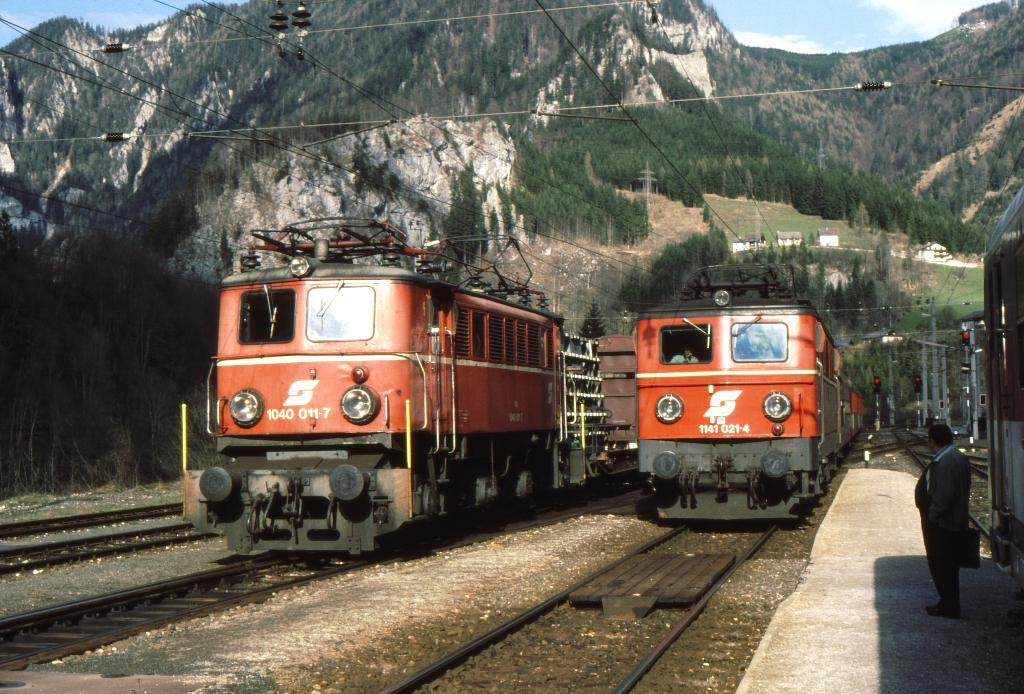<image>
Give a short and clear explanation of the subsequent image. two orange trains are sitting on the tracks, one is number 1040 011 7 